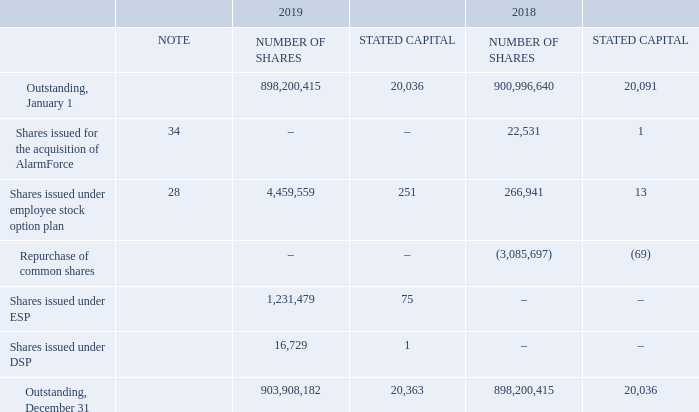COMMON SHARES AND CLASS B SHARES
BCE’s articles of amalgamation provide for an unlimited number of voting common shares and non-voting Class B shares, all without par value. The common shares and the Class B shares rank equally in the payment of dividends and in the distribution of assets if BCE is liquidated, dissolved or wound up, after payments due to the holders of preferred shares. No Class B shares were outstanding at December 31, 2019 and 2018.
The following table provides details about the outstanding common shares of BCE.
In Q1 2018, BCE repurchased and canceled 3,085,697 common shares for a total cost of $175 million through a NCIB. Of the total cost, $69 million represents stated capital and $3 million represents the reduction of the contributed surplus attributable to these common shares. The remaining $103 million was charged to the deficit.
CONTRIBUTED SURPLUS
Contributed surplus in 2019 and 2018 includes premiums in excess of par value upon the issuance of BCE common shares and share-based compensation expense net of settlements.
How many common shares did BCE repurchase in 2018? 3,085,697. What is the amount of stated capital outstanding on December 31, 2019 20,363. What comprised of the total cost that went into the repurchase of common shares in 2018? Stated capital, reduction of the contributed surplus attributable to these common shares, charged to the deficit. What is the percentage of the value charged to the deficit expressed as a percentage of total cost of common shares?
Answer scale should be: percent. 103/175
Answer: 58.86. What was the total number of shares issued under ESP and DSP in 2019? 1,231,479+16,729
Answer: 1248208. What is the percentage change in the total number of shares in 2019?
Answer scale should be: percent. (898,200,415-900,996,640)/900,996,640
Answer: -0.31. 